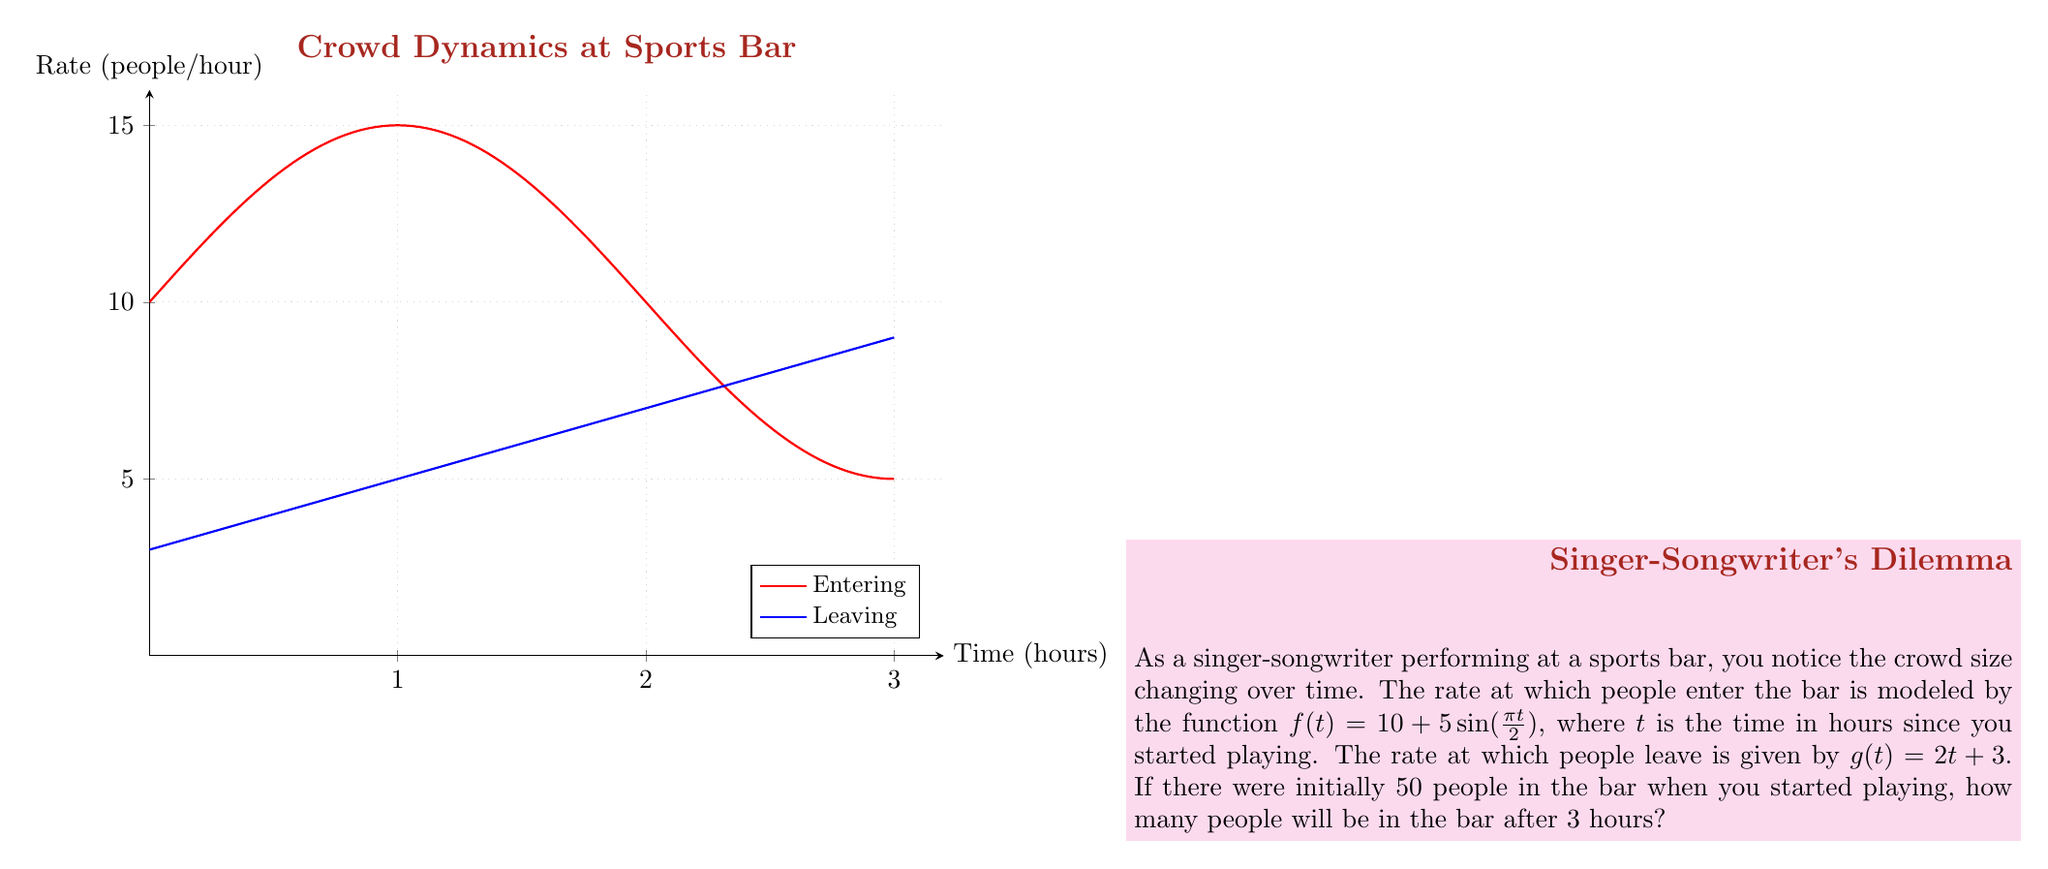Can you answer this question? Let's approach this step-by-step:

1) The change in crowd size can be modeled by the differential equation:

   $$\frac{dN}{dt} = f(t) - g(t)$$

   where $N$ is the number of people in the bar.

2) Substituting the given functions:

   $$\frac{dN}{dt} = (10 + 5\sin(\frac{\pi t}{2})) - (2t + 3)$$

3) To find the number of people after 3 hours, we need to integrate this equation:

   $$N(t) = \int_0^t (7 + 5\sin(\frac{\pi \tau}{2}) - 2\tau) d\tau + 50$$

4) Let's integrate each term:

   $$\int 7 d\tau = 7\tau$$
   $$\int 5\sin(\frac{\pi \tau}{2}) d\tau = -\frac{10}{\pi}\cos(\frac{\pi \tau}{2})$$
   $$\int -2\tau d\tau = -\tau^2$$

5) Putting it all together:

   $$N(t) = [7\tau - \frac{10}{\pi}\cos(\frac{\pi \tau}{2}) - \tau^2]_0^t + 50$$

6) Evaluating at $t=3$:

   $$N(3) = [21 - \frac{10}{\pi}\cos(\frac{3\pi}{2}) - 9] - [0 - \frac{10}{\pi} - 0] + 50$$

7) Simplifying:

   $$N(3) = 12 + \frac{10}{\pi} + \frac{10}{\pi} + 50 = 62 + \frac{20}{\pi}$$

8) This evaluates to approximately 68.36 people.
Answer: 68 people (rounded to nearest whole number) 